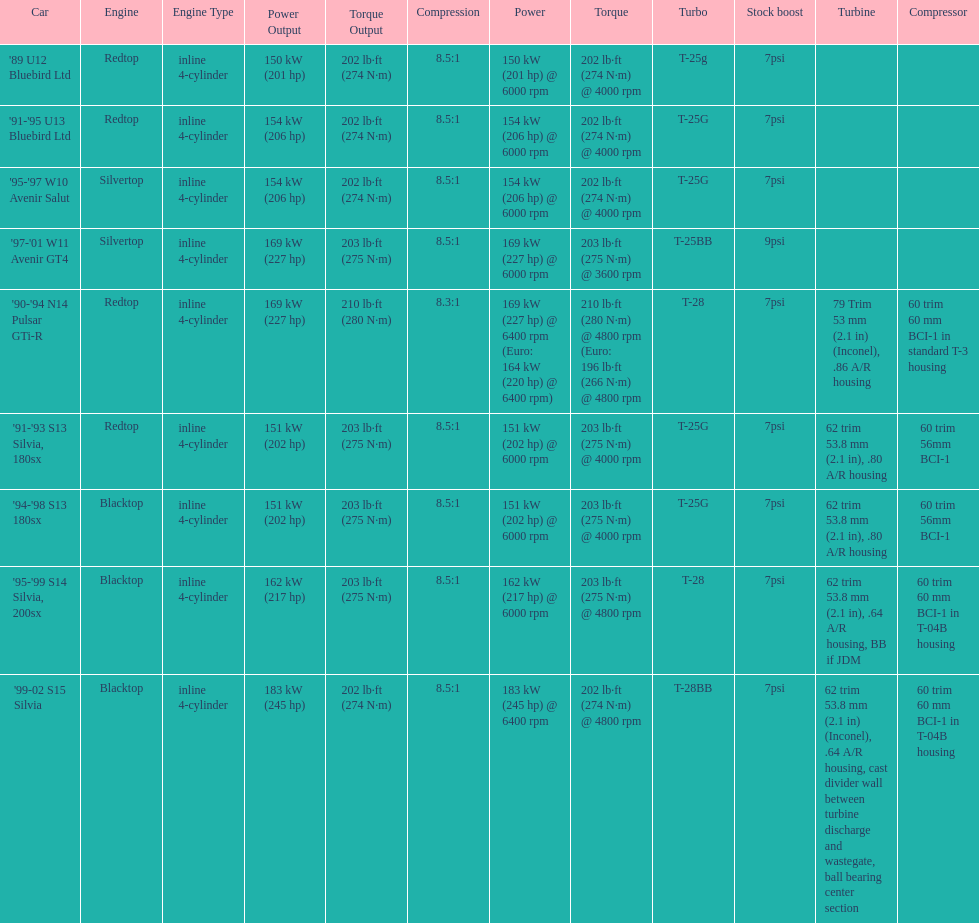Which car's power measured at higher than 6000 rpm? '90-'94 N14 Pulsar GTi-R, '99-02 S15 Silvia. 